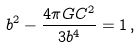<formula> <loc_0><loc_0><loc_500><loc_500>b ^ { 2 } - { \frac { 4 \pi G C ^ { 2 } } { 3 b ^ { 4 } } } = 1 \, ,</formula> 